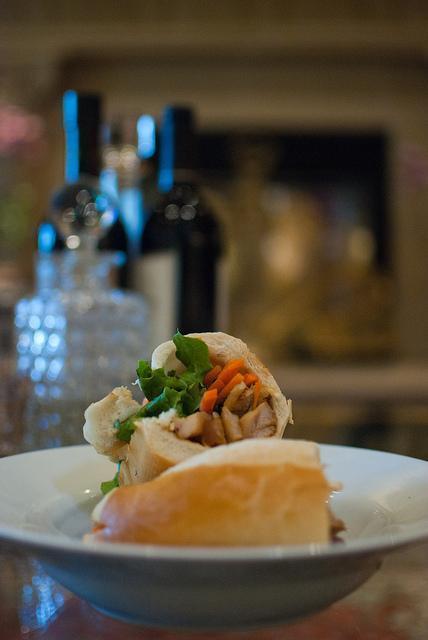How many bottles are there?
Give a very brief answer. 3. How many horses are on the track?
Give a very brief answer. 0. 